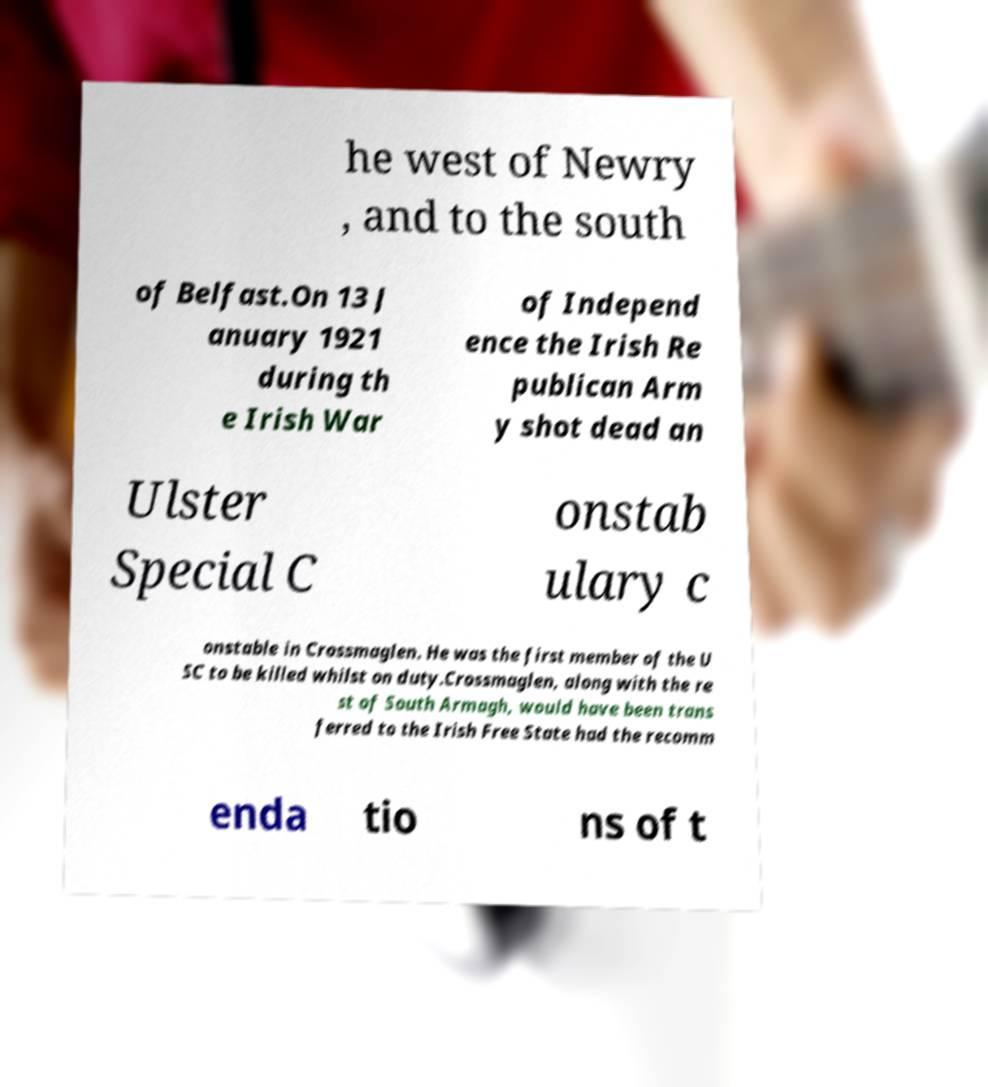What messages or text are displayed in this image? I need them in a readable, typed format. he west of Newry , and to the south of Belfast.On 13 J anuary 1921 during th e Irish War of Independ ence the Irish Re publican Arm y shot dead an Ulster Special C onstab ulary c onstable in Crossmaglen. He was the first member of the U SC to be killed whilst on duty.Crossmaglen, along with the re st of South Armagh, would have been trans ferred to the Irish Free State had the recomm enda tio ns of t 